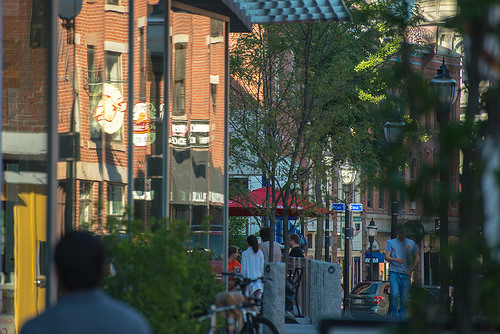<image>
Is the women on the man? No. The women is not positioned on the man. They may be near each other, but the women is not supported by or resting on top of the man. 